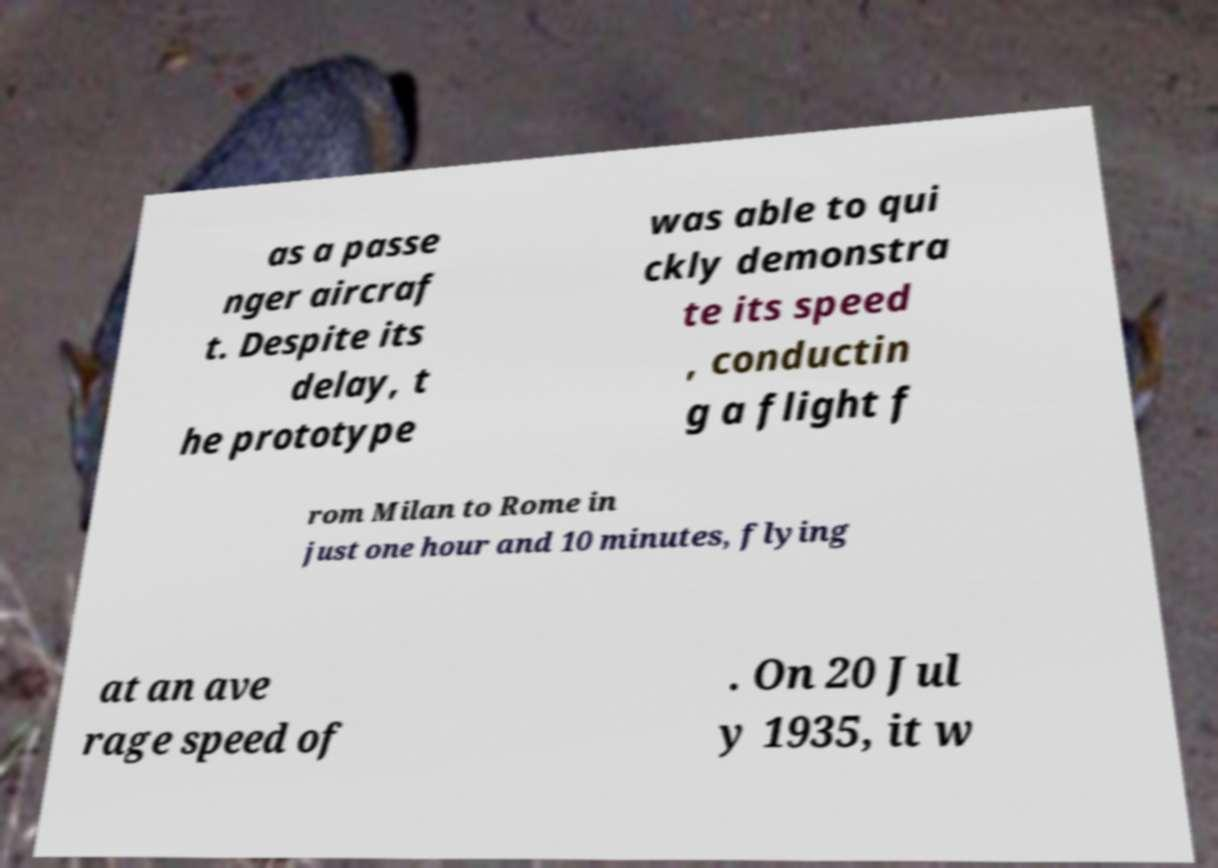Could you assist in decoding the text presented in this image and type it out clearly? as a passe nger aircraf t. Despite its delay, t he prototype was able to qui ckly demonstra te its speed , conductin g a flight f rom Milan to Rome in just one hour and 10 minutes, flying at an ave rage speed of . On 20 Jul y 1935, it w 